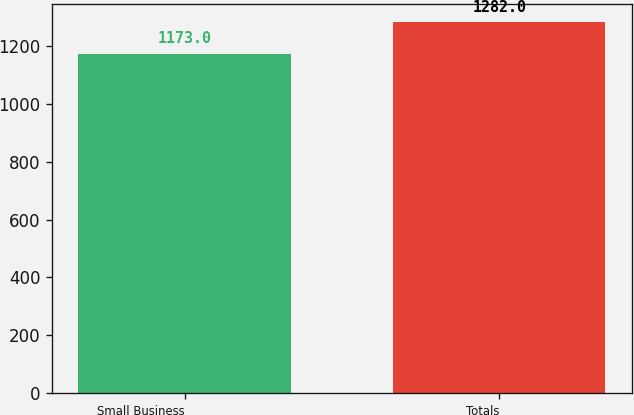Convert chart. <chart><loc_0><loc_0><loc_500><loc_500><bar_chart><fcel>Small Business<fcel>Totals<nl><fcel>1173<fcel>1282<nl></chart> 